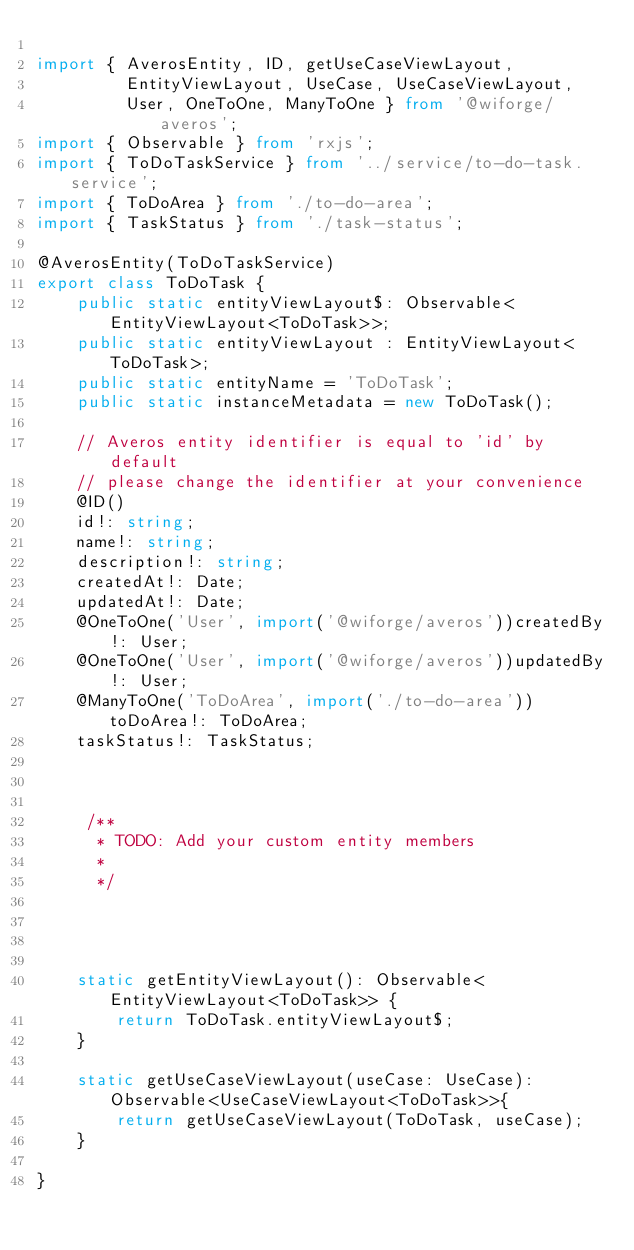Convert code to text. <code><loc_0><loc_0><loc_500><loc_500><_TypeScript_>
import { AverosEntity, ID, getUseCaseViewLayout, 
         EntityViewLayout, UseCase, UseCaseViewLayout, 
         User, OneToOne, ManyToOne } from '@wiforge/averos';
import { Observable } from 'rxjs';
import { ToDoTaskService } from '../service/to-do-task.service';
import { ToDoArea } from './to-do-area';
import { TaskStatus } from './task-status';

@AverosEntity(ToDoTaskService)
export class ToDoTask {
    public static entityViewLayout$: Observable<EntityViewLayout<ToDoTask>>;
    public static entityViewLayout : EntityViewLayout<ToDoTask>;
    public static entityName = 'ToDoTask';
    public static instanceMetadata = new ToDoTask();

    // Averos entity identifier is equal to 'id' by default
    // please change the identifier at your convenience
    @ID()
    id!: string;
    name!: string;
    description!: string;
    createdAt!: Date;
    updatedAt!: Date;
    @OneToOne('User', import('@wiforge/averos'))createdBy!: User;
    @OneToOne('User', import('@wiforge/averos'))updatedBy!: User;
    @ManyToOne('ToDoArea', import('./to-do-area')) toDoArea!: ToDoArea;
    taskStatus!: TaskStatus;


     
     /**
      * TODO: Add your custom entity members
      *
      */




    static getEntityViewLayout(): Observable<EntityViewLayout<ToDoTask>> {
        return ToDoTask.entityViewLayout$;
    }

    static getUseCaseViewLayout(useCase: UseCase): Observable<UseCaseViewLayout<ToDoTask>>{
        return getUseCaseViewLayout(ToDoTask, useCase);
    }

}</code> 